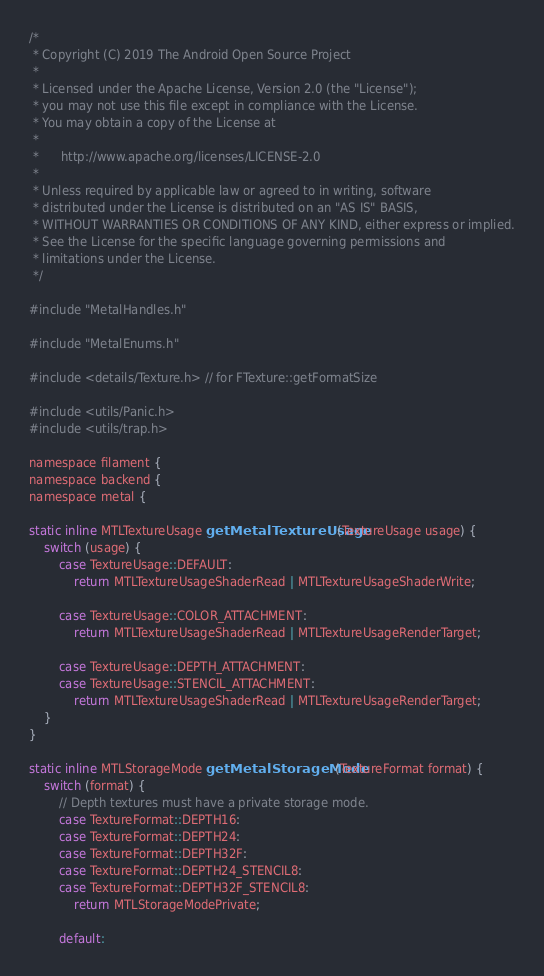<code> <loc_0><loc_0><loc_500><loc_500><_ObjectiveC_>/*
 * Copyright (C) 2019 The Android Open Source Project
 *
 * Licensed under the Apache License, Version 2.0 (the "License");
 * you may not use this file except in compliance with the License.
 * You may obtain a copy of the License at
 *
 *      http://www.apache.org/licenses/LICENSE-2.0
 *
 * Unless required by applicable law or agreed to in writing, software
 * distributed under the License is distributed on an "AS IS" BASIS,
 * WITHOUT WARRANTIES OR CONDITIONS OF ANY KIND, either express or implied.
 * See the License for the specific language governing permissions and
 * limitations under the License.
 */

#include "MetalHandles.h"

#include "MetalEnums.h"

#include <details/Texture.h> // for FTexture::getFormatSize

#include <utils/Panic.h>
#include <utils/trap.h>

namespace filament {
namespace backend {
namespace metal {

static inline MTLTextureUsage getMetalTextureUsage(TextureUsage usage) {
    switch (usage) {
        case TextureUsage::DEFAULT:
            return MTLTextureUsageShaderRead | MTLTextureUsageShaderWrite;

        case TextureUsage::COLOR_ATTACHMENT:
            return MTLTextureUsageShaderRead | MTLTextureUsageRenderTarget;

        case TextureUsage::DEPTH_ATTACHMENT:
        case TextureUsage::STENCIL_ATTACHMENT:
            return MTLTextureUsageShaderRead | MTLTextureUsageRenderTarget;
    }
}

static inline MTLStorageMode getMetalStorageMode(TextureFormat format) {
    switch (format) {
        // Depth textures must have a private storage mode.
        case TextureFormat::DEPTH16:
        case TextureFormat::DEPTH24:
        case TextureFormat::DEPTH32F:
        case TextureFormat::DEPTH24_STENCIL8:
        case TextureFormat::DEPTH32F_STENCIL8:
            return MTLStorageModePrivate;

        default:</code> 